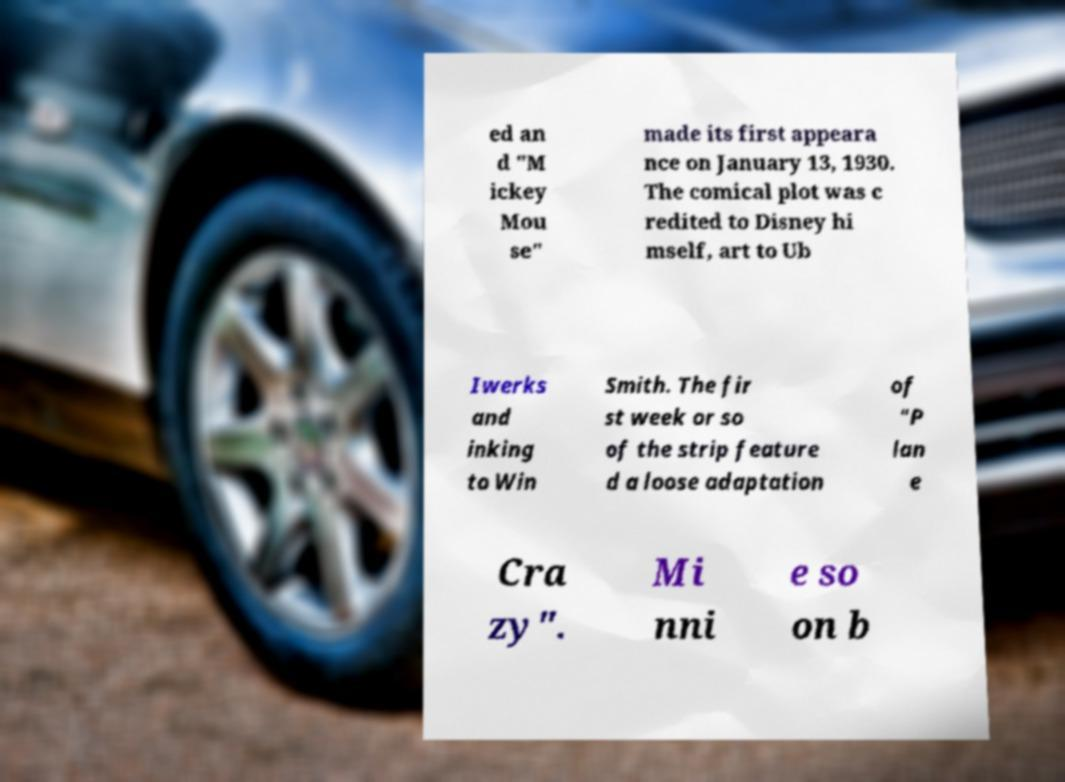Could you assist in decoding the text presented in this image and type it out clearly? ed an d "M ickey Mou se" made its first appeara nce on January 13, 1930. The comical plot was c redited to Disney hi mself, art to Ub Iwerks and inking to Win Smith. The fir st week or so of the strip feature d a loose adaptation of "P lan e Cra zy". Mi nni e so on b 